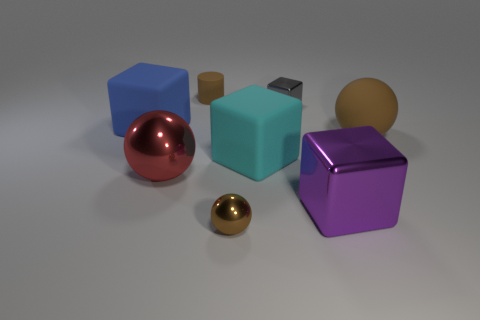Subtract all purple cubes. How many cubes are left? 3 Add 2 red things. How many objects exist? 10 Subtract all purple cylinders. How many brown spheres are left? 2 Subtract 2 blocks. How many blocks are left? 2 Subtract all spheres. How many objects are left? 5 Subtract all blue blocks. How many blocks are left? 3 Subtract all red blocks. Subtract all blue cylinders. How many blocks are left? 4 Subtract all large cyan things. Subtract all small rubber cylinders. How many objects are left? 6 Add 5 gray blocks. How many gray blocks are left? 6 Add 7 red shiny objects. How many red shiny objects exist? 8 